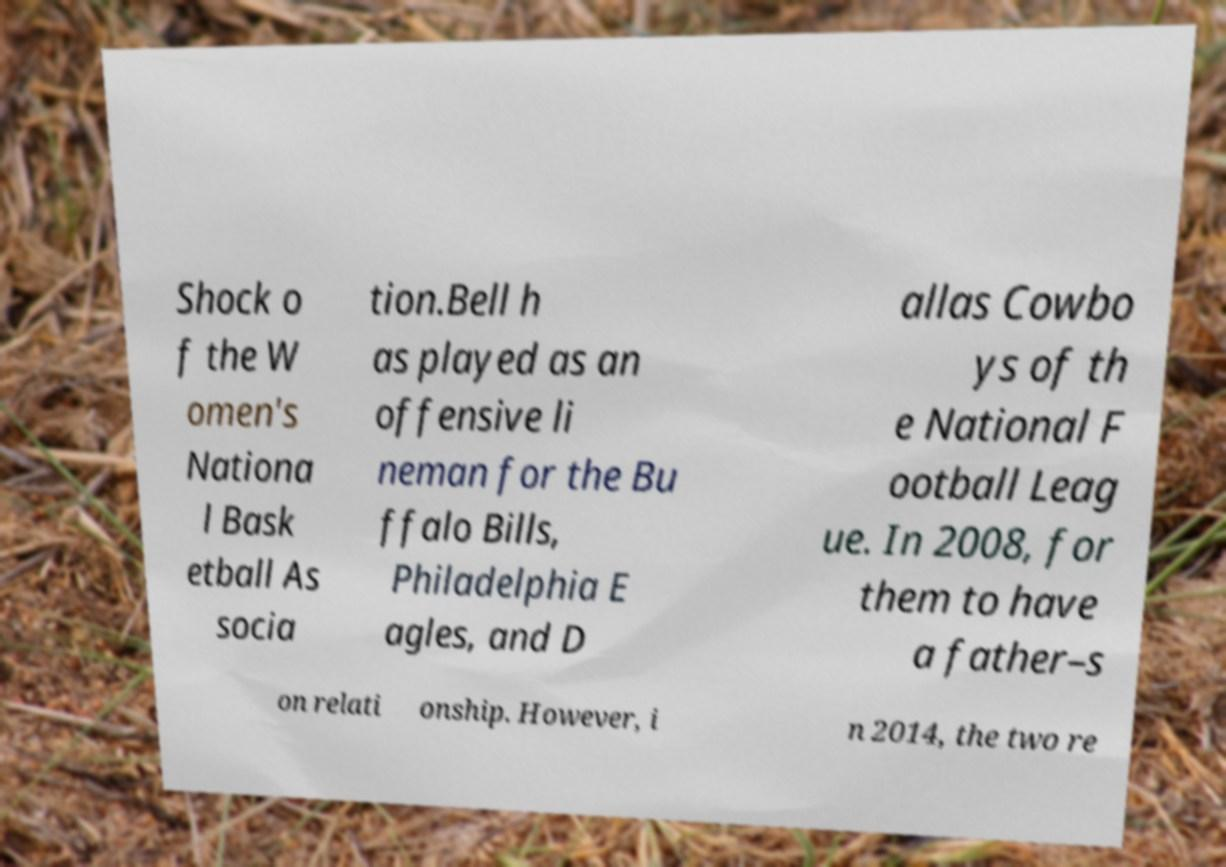Please read and relay the text visible in this image. What does it say? Shock o f the W omen's Nationa l Bask etball As socia tion.Bell h as played as an offensive li neman for the Bu ffalo Bills, Philadelphia E agles, and D allas Cowbo ys of th e National F ootball Leag ue. In 2008, for them to have a father–s on relati onship. However, i n 2014, the two re 